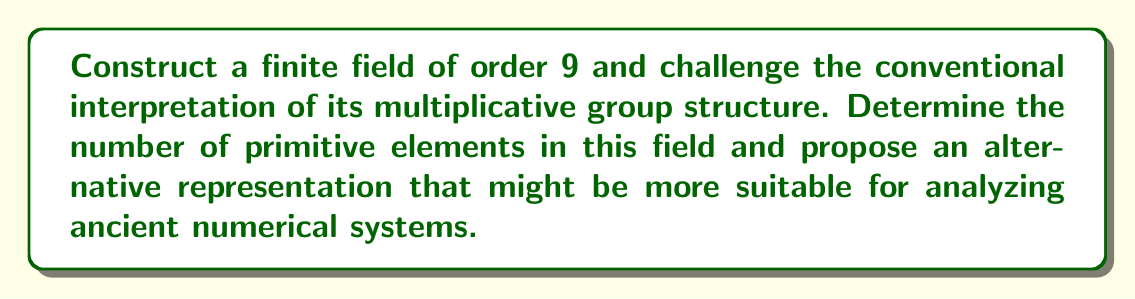Can you answer this question? 1. Construct the finite field of order 9:
   - We can construct this field as $\mathbb{F}_9 = \mathbb{F}_3[x]/(x^2+1)$
   - The elements are of the form $a+bx$ where $a,b \in \{0,1,2\}$ and $x^2 = -1 = 2$ in $\mathbb{F}_3$

2. Define the field operations:
   - Addition: $(a_1+b_1x) + (a_2+b_2x) = ((a_1+a_2) \mod 3) + ((b_1+b_2) \mod 3)x$
   - Multiplication: $(a_1+b_1x)(a_2+b_2x) = (a_1a_2-b_1b_2) + (a_1b_2+a_2b_1)x$ (mod 3)

3. List all elements of $\mathbb{F}_9$:
   $\{0, 1, 2, x, 2x, 1+x, 1+2x, 2+x, 2+2x\}$

4. Analyze the multiplicative group structure:
   - The multiplicative group $\mathbb{F}_9^* = \mathbb{F}_9 \setminus \{0\}$ has order 8
   - Conventionally, this group is isomorphic to $\mathbb{Z}_8$

5. Determine primitive elements:
   - A primitive element generates the entire multiplicative group
   - Check each non-zero element by computing its powers until reaching 1
   - Primitive elements: $\{x, 2x, 1+x, 2+2x\}$

6. Alternative representation:
   - Instead of viewing $\mathbb{F}_9^*$ as cyclic, represent it as $\mathbb{Z}_2 \times \mathbb{Z}_4$
   - This representation might better reflect ancient numerical systems that used composite number bases

7. Mapping to $\mathbb{Z}_2 \times \mathbb{Z}_4$:
   - Define $\phi: \mathbb{F}_9^* \to \mathbb{Z}_2 \times \mathbb{Z}_4$
   - $\phi(1) = (0,0)$, $\phi(2) = (1,0)$
   - $\phi(x) = (0,1)$, $\phi(2x) = (1,1)$
   - $\phi(1+x) = (0,2)$, $\phi(1+2x) = (1,2)$
   - $\phi(2+x) = (0,3)$, $\phi(2+2x) = (1,3)$

This alternative representation challenges the conventional cyclic interpretation and may provide insights into ancient numerical systems that used composite bases.
Answer: $\mathbb{F}_9 = \mathbb{F}_3[x]/(x^2+1)$, 4 primitive elements, $\mathbb{F}_9^* \cong \mathbb{Z}_2 \times \mathbb{Z}_4$ 